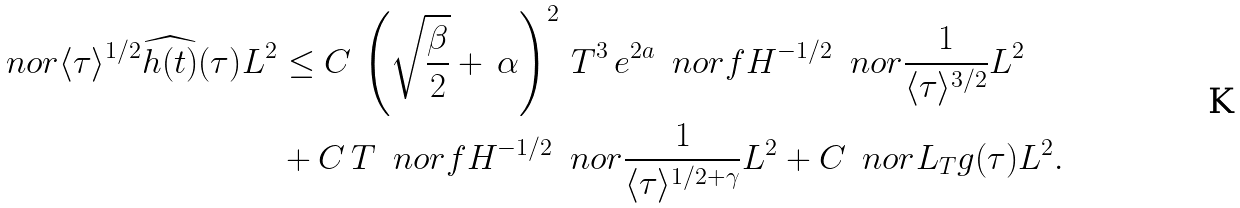<formula> <loc_0><loc_0><loc_500><loc_500>\ n o r { \langle \tau \rangle ^ { 1 / 2 } \widehat { h ( t ) } ( \tau ) } { L ^ { 2 } } & \leq C \, \left ( \sqrt { \frac { \beta } { 2 } } + \, \alpha \right ) ^ { 2 } \, T ^ { 3 } \, e ^ { 2 a } \, \ n o r { f } { H ^ { - 1 / 2 } } \, \ n o r { \frac { 1 } { \langle \tau \rangle ^ { 3 / 2 } } } { L ^ { 2 } } \\ & + C \, T \, \ n o r { f } { H ^ { - 1 / 2 } } \, \ n o r { \frac { 1 } { \langle \tau \rangle ^ { 1 / 2 + \gamma } } } { L ^ { 2 } } + C \, \ n o r { L _ { T } g ( \tau ) } { L ^ { 2 } } .</formula> 